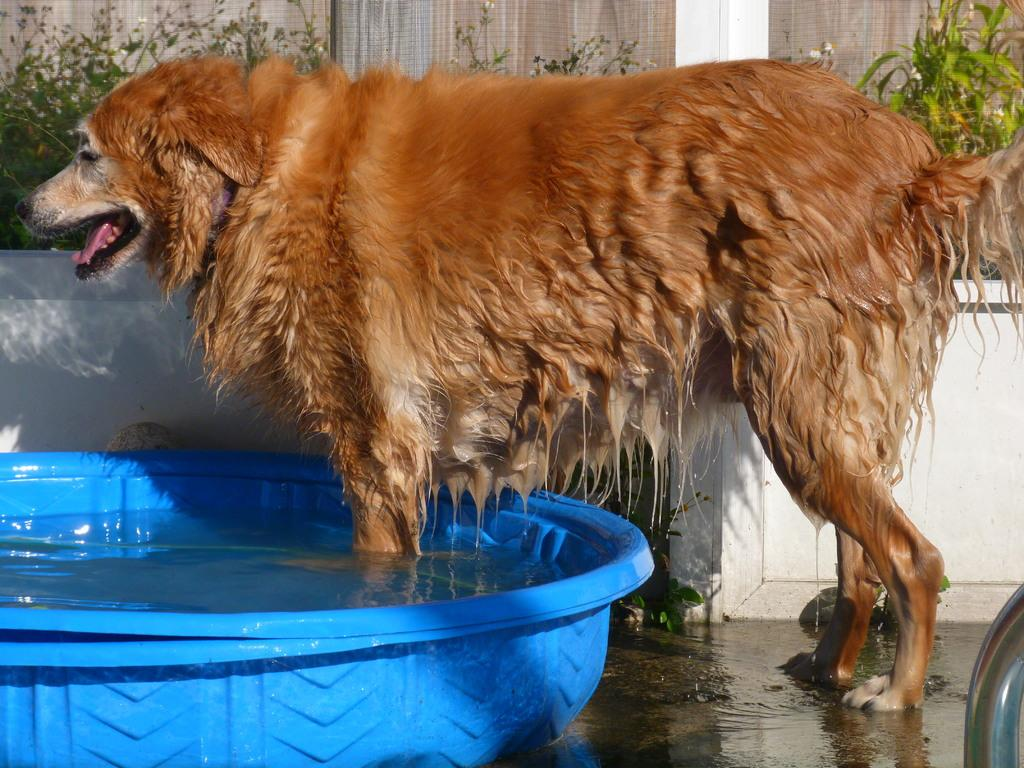What type of animal is in the image? There is a dog in the image. Where is the dog positioned in the image? The dog is standing on the floor. What is the dog doing with its front legs? The dog's front legs are in a tub of water. What can be seen in the background of the image? There are walls and plants visible in the background of the image. What type of actor is performing in the image? There is no actor present in the image; it features a dog standing with its front legs in a tub of water. Can you provide an example of a similar image with a different animal? The provided image features a dog, so an example with a different animal would be an image of a cat standing with its front legs in a tub of water. 